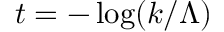Convert formula to latex. <formula><loc_0><loc_0><loc_500><loc_500>t = - \log ( k / \Lambda )</formula> 